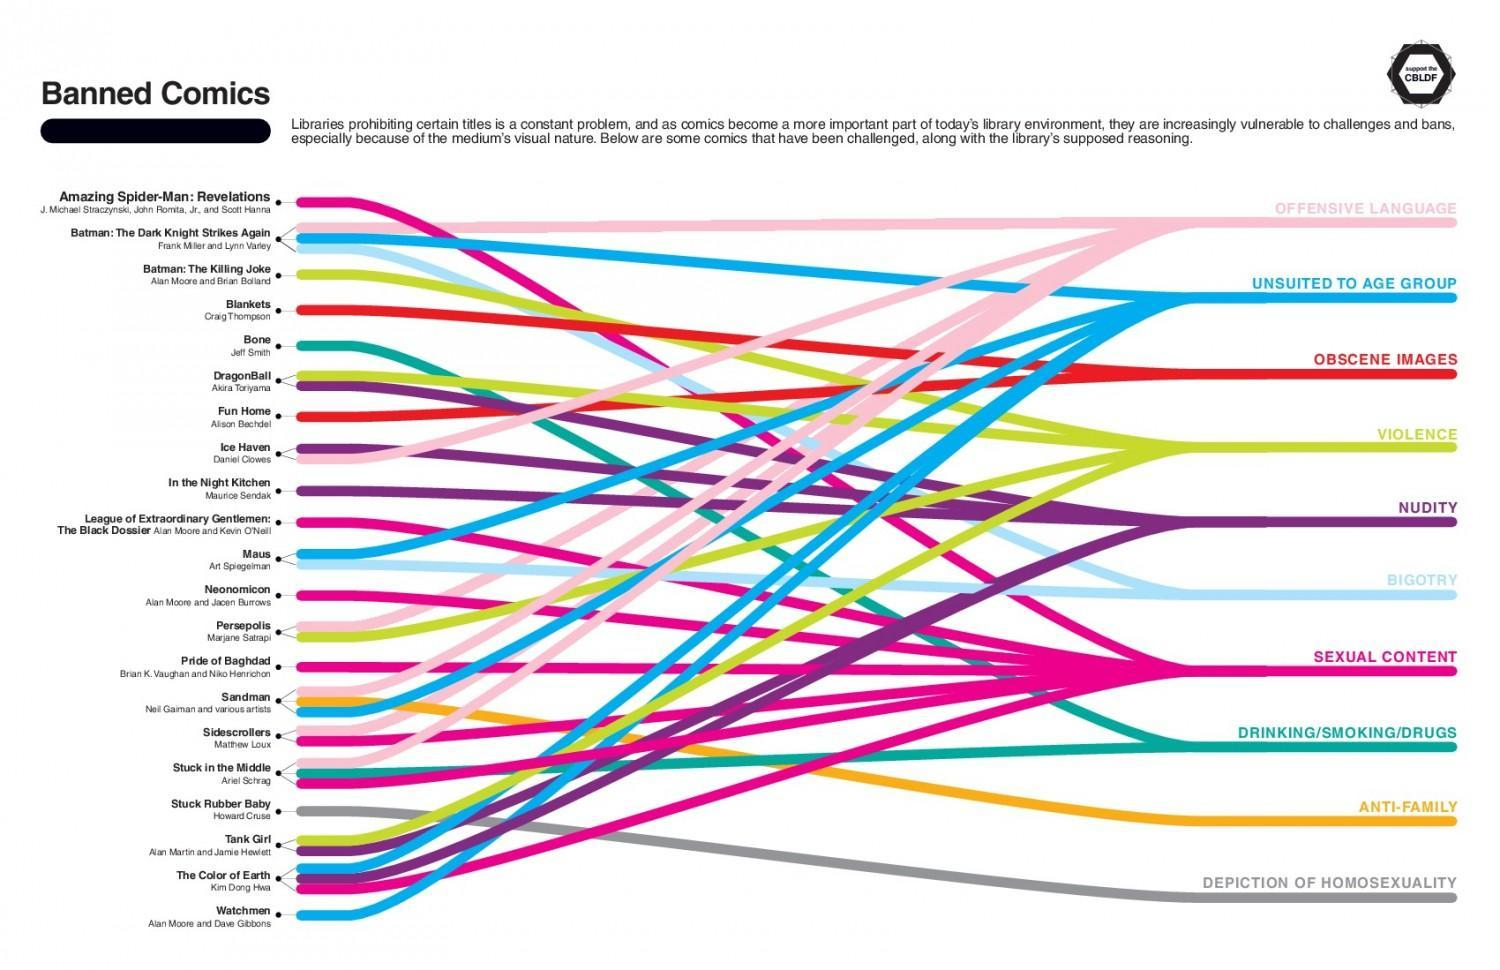What is the reason for banning the comic book called 'Bone'?
Answer the question with a short phrase. DRINKING/SMOKING/DRUGS Which comic book written by Howard Cruse is banned due to the depiction of homosexuality? Stuck Rubber Baby Who is the author of 'Fun Home'? Alison Bechdel What are the reasons for banning the comic book 'Maus'? UNSUITED TO AGE GROUP, BIGOTRY Which comic book is banned due to anti-family themes among the given comics? Sandman Who is the author of 'Ice Haven'? Daniel Clowes What is the reason for banning the comic book called 'Watchmen'? UNSUITED TO AGE GROUP Which comic book written by Craig Thompson is banned due to obscene images? Blankets 